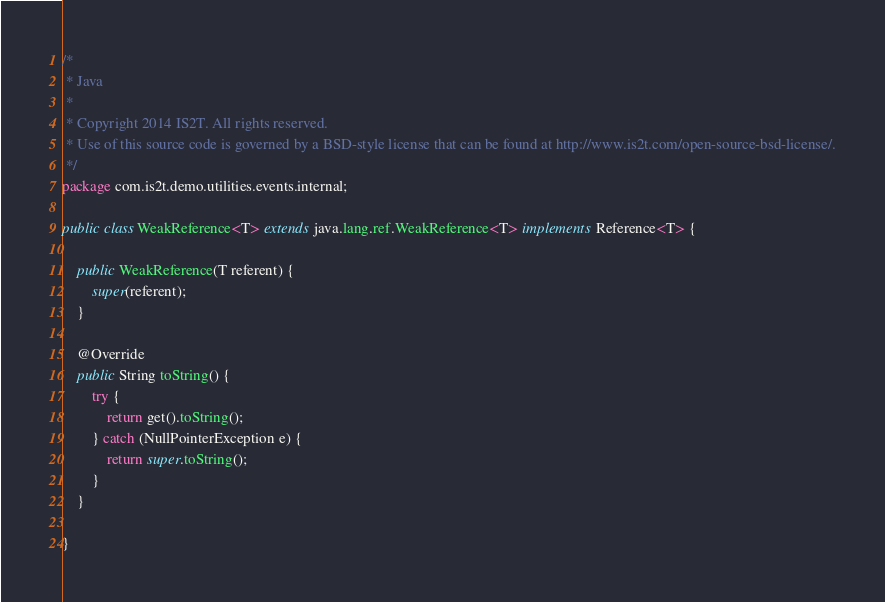Convert code to text. <code><loc_0><loc_0><loc_500><loc_500><_Java_>/*
 * Java
 *
 * Copyright 2014 IS2T. All rights reserved.
 * Use of this source code is governed by a BSD-style license that can be found at http://www.is2t.com/open-source-bsd-license/.
 */
package com.is2t.demo.utilities.events.internal;

public class WeakReference<T> extends java.lang.ref.WeakReference<T> implements Reference<T> {

	public WeakReference(T referent) {
		super(referent);
	}

	@Override
	public String toString() {
		try {
			return get().toString();
		} catch (NullPointerException e) {
			return super.toString();
		}
	}

}
</code> 